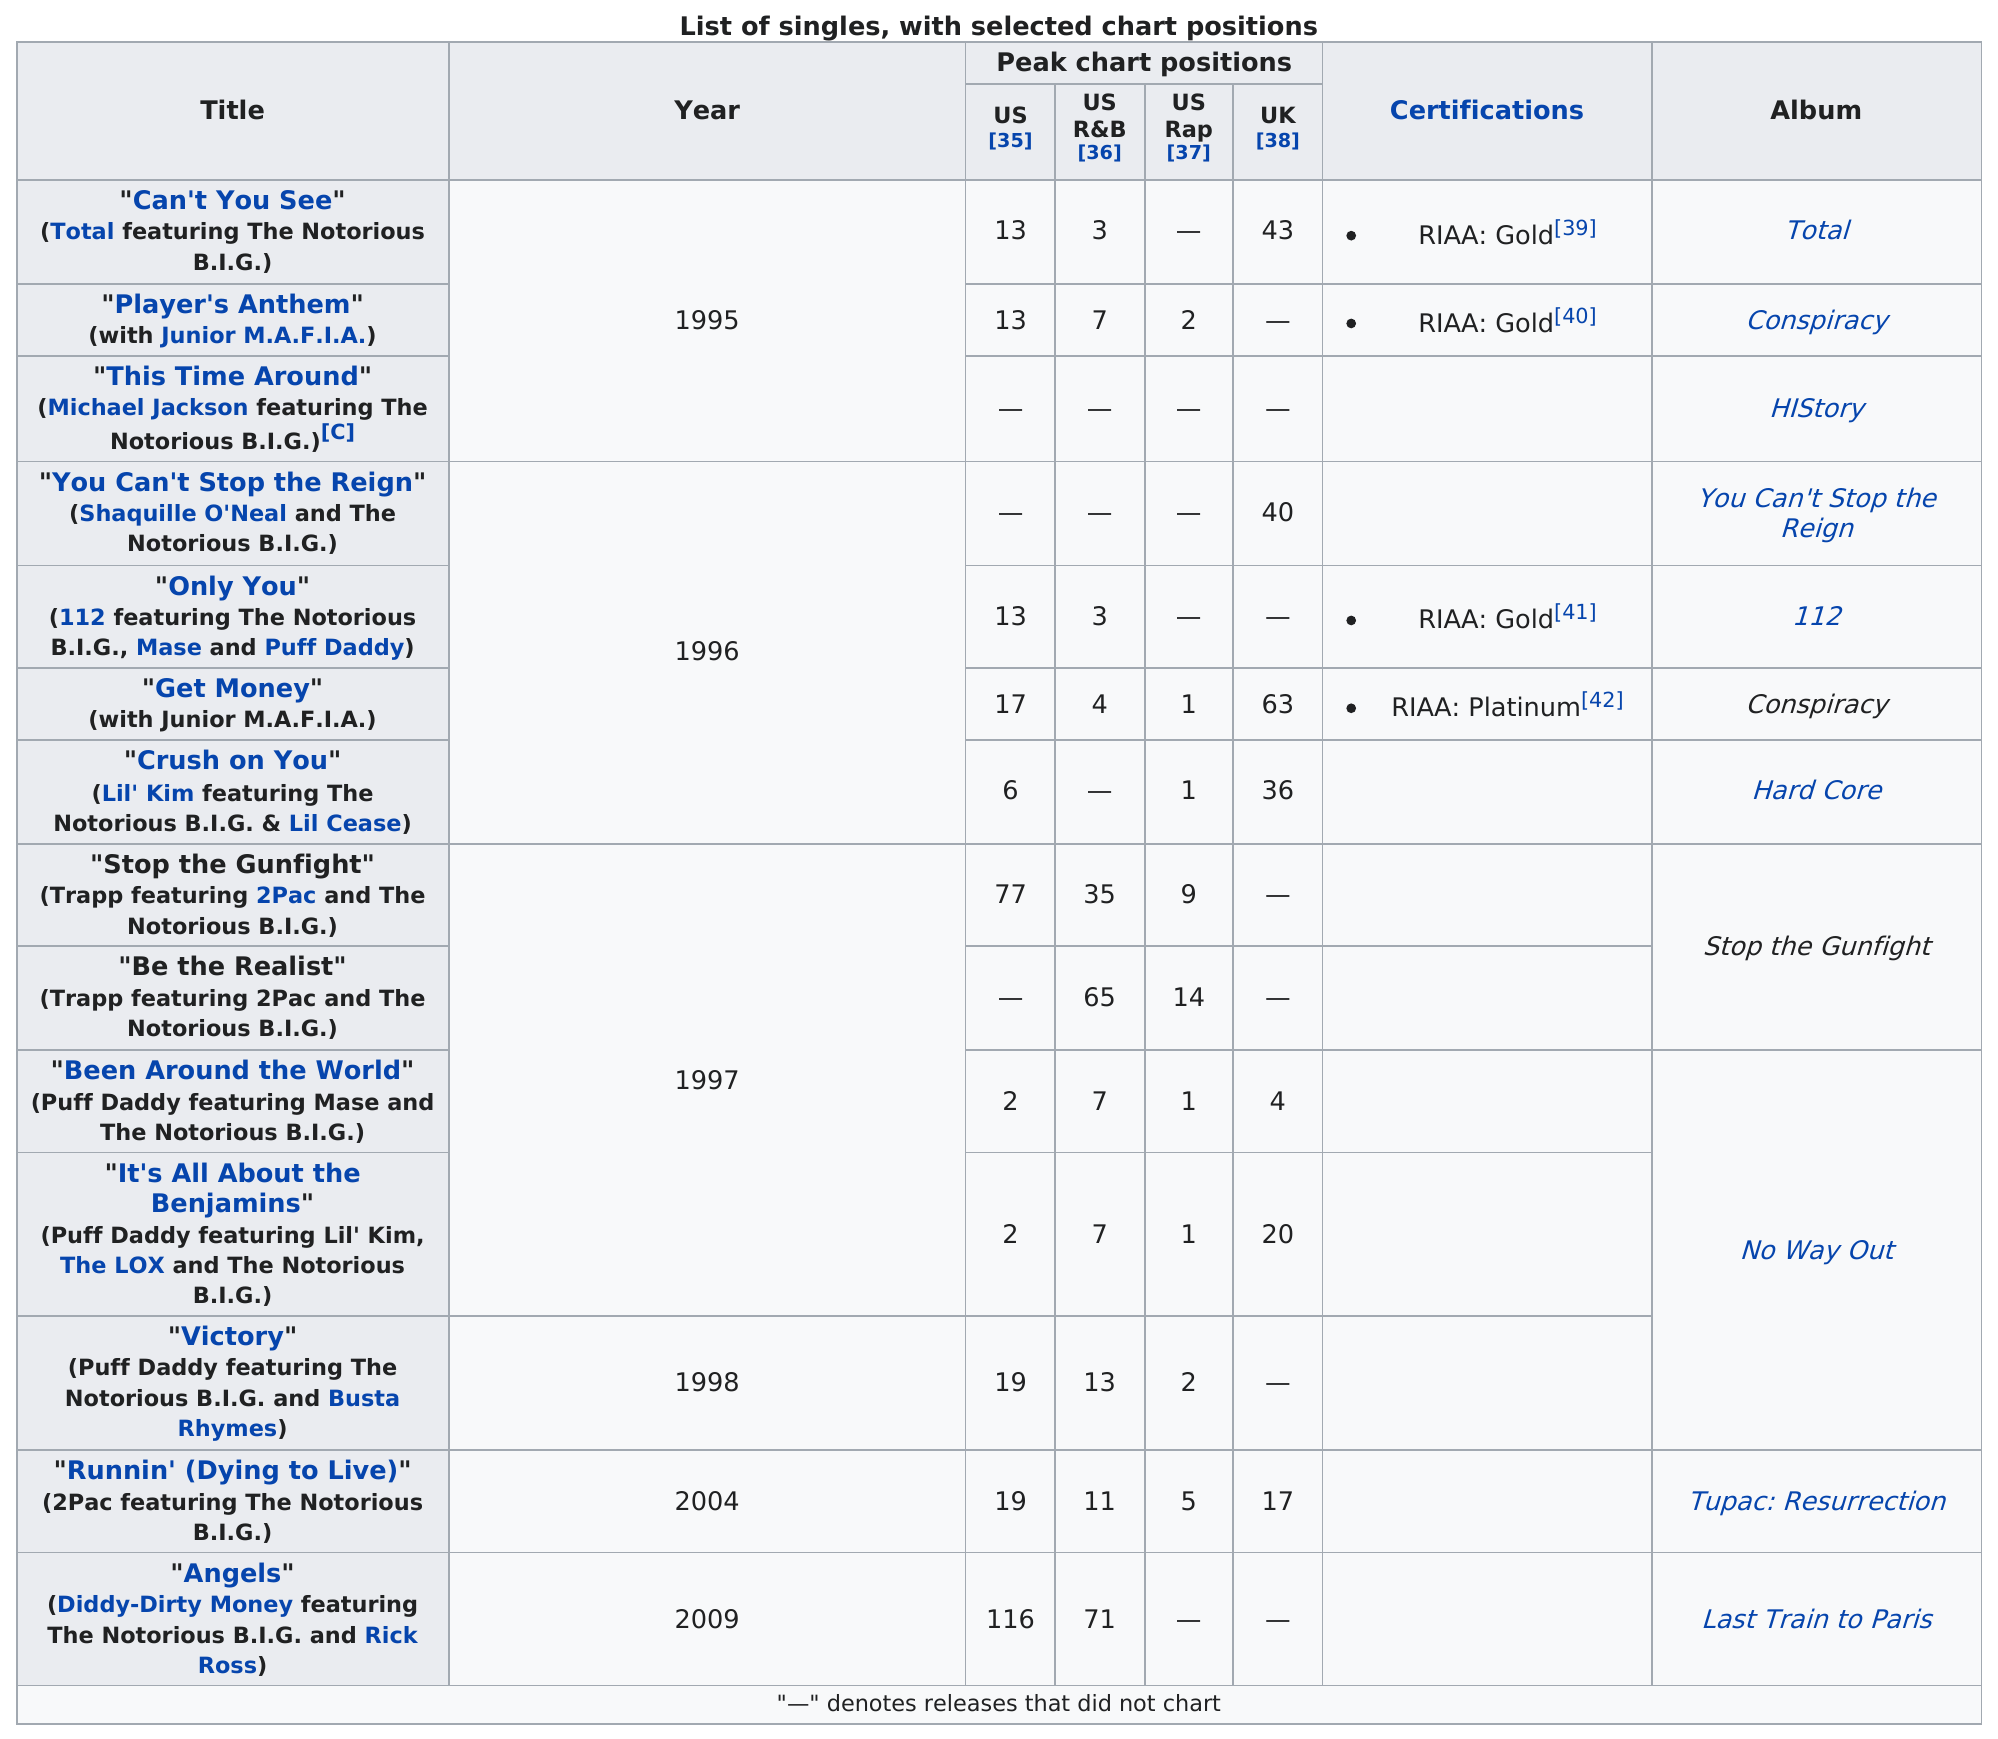Indicate a few pertinent items in this graphic. In 1997, a total of 4 songs were released that featured the late rapper Notorious B.I.G. Biggie Smalls, also known as Notorious B.I.G., did not release a single after the release of his album "Victory." One of his post-"Victory" releases was the song "Runnin' (Dying to Live). The last released featured performance by Notorious B.I.G. was "Angels" (Diddy-Dirty Money featuring The Notorious B.I.G. and Rick Ross). The Notorious B.I.G. released a total of 4 singles in 1996. The least number of chart positions was obtained by the feature titled "This Time Around" by Michael Jackson featuring The Notorious B.I.G., which is a hip hop song. 